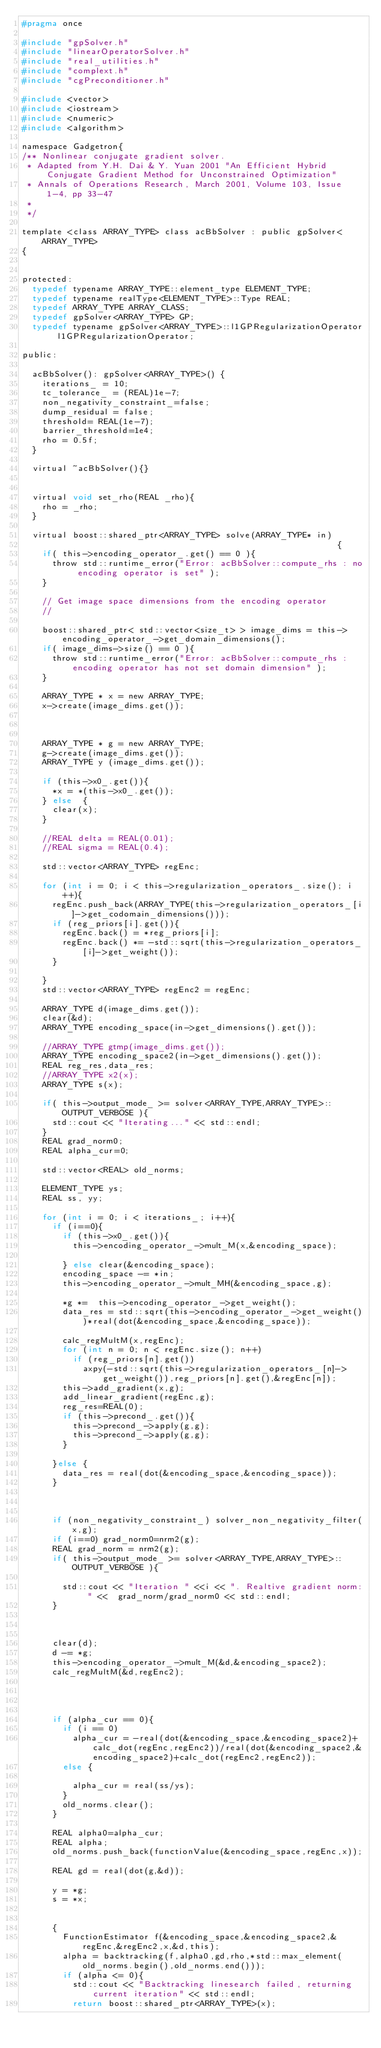Convert code to text. <code><loc_0><loc_0><loc_500><loc_500><_C_>#pragma once

#include "gpSolver.h"
#include "linearOperatorSolver.h"
#include "real_utilities.h"
#include "complext.h"
#include "cgPreconditioner.h"

#include <vector>
#include <iostream>
#include <numeric>
#include <algorithm>

namespace Gadgetron{
/** Nonlinear conjugate gradient solver.
 * Adapted from Y.H. Dai & Y. Yuan 2001 "An Efficient Hybrid Conjugate Gradient Method for Unconstrained Optimization"
 * Annals of Operations Research, March 2001, Volume 103, Issue 1-4, pp 33-47
 *
 */

template <class ARRAY_TYPE> class acBbSolver : public gpSolver<ARRAY_TYPE>
{


protected:
	typedef typename ARRAY_TYPE::element_type ELEMENT_TYPE;
	typedef typename realType<ELEMENT_TYPE>::Type REAL;
	typedef ARRAY_TYPE ARRAY_CLASS;
	typedef gpSolver<ARRAY_TYPE> GP;
	typedef typename gpSolver<ARRAY_TYPE>::l1GPRegularizationOperator l1GPRegularizationOperator;

public:

	acBbSolver(): gpSolver<ARRAY_TYPE>() {
		iterations_ = 10;
		tc_tolerance_ = (REAL)1e-7;
		non_negativity_constraint_=false;
		dump_residual = false;
		threshold= REAL(1e-7);
		barrier_threshold=1e4;
		rho = 0.5f;
	}

	virtual ~acBbSolver(){}


	virtual void set_rho(REAL _rho){
		rho = _rho;
	}

	virtual boost::shared_ptr<ARRAY_TYPE> solve(ARRAY_TYPE* in)
																															{
		if( this->encoding_operator_.get() == 0 ){
			throw std::runtime_error("Error: acBbSolver::compute_rhs : no encoding operator is set" );
		}

		// Get image space dimensions from the encoding operator
		//

		boost::shared_ptr< std::vector<size_t> > image_dims = this->encoding_operator_->get_domain_dimensions();
		if( image_dims->size() == 0 ){
			throw std::runtime_error("Error: acBbSolver::compute_rhs : encoding operator has not set domain dimension" );
		}

		ARRAY_TYPE * x = new ARRAY_TYPE;
		x->create(image_dims.get());



		ARRAY_TYPE * g = new ARRAY_TYPE;
		g->create(image_dims.get());
		ARRAY_TYPE y (image_dims.get());

		if (this->x0_.get()){
			*x = *(this->x0_.get());
		} else  {
			clear(x);
		}

		//REAL delta = REAL(0.01);
		//REAL sigma = REAL(0.4);

		std::vector<ARRAY_TYPE> regEnc;

		for (int i = 0; i < this->regularization_operators_.size(); i++){
			regEnc.push_back(ARRAY_TYPE(this->regularization_operators_[i]->get_codomain_dimensions()));
			if (reg_priors[i].get()){
				regEnc.back() = *reg_priors[i];
				regEnc.back() *= -std::sqrt(this->regularization_operators_[i]->get_weight());
			}

		}
		std::vector<ARRAY_TYPE> regEnc2 = regEnc;

		ARRAY_TYPE d(image_dims.get());
		clear(&d);
		ARRAY_TYPE encoding_space(in->get_dimensions().get());

		//ARRAY_TYPE gtmp(image_dims.get());
		ARRAY_TYPE encoding_space2(in->get_dimensions().get());
		REAL reg_res,data_res;
		//ARRAY_TYPE x2(x);
		ARRAY_TYPE s(x);

		if( this->output_mode_ >= solver<ARRAY_TYPE,ARRAY_TYPE>::OUTPUT_VERBOSE ){
			std::cout << "Iterating..." << std::endl;
		}
		REAL grad_norm0;
		REAL alpha_cur=0;

		std::vector<REAL> old_norms;

		ELEMENT_TYPE ys;
		REAL ss, yy;

		for (int i = 0; i < iterations_; i++){
			if (i==0){
				if (this->x0_.get()){
					this->encoding_operator_->mult_M(x,&encoding_space);

				} else clear(&encoding_space);
				encoding_space -= *in;
				this->encoding_operator_->mult_MH(&encoding_space,g);

				*g *=  this->encoding_operator_->get_weight();
				data_res = std::sqrt(this->encoding_operator_->get_weight())*real(dot(&encoding_space,&encoding_space));

				calc_regMultM(x,regEnc);
				for (int n = 0; n < regEnc.size(); n++)
					if (reg_priors[n].get())
						axpy(-std::sqrt(this->regularization_operators_[n]->get_weight()),reg_priors[n].get(),&regEnc[n]);
				this->add_gradient(x,g);
				add_linear_gradient(regEnc,g);
				reg_res=REAL(0);
				if (this->precond_.get()){
					this->precond_->apply(g,g);
					this->precond_->apply(g,g);
				}

			}else {
				data_res = real(dot(&encoding_space,&encoding_space));
			}



			if (non_negativity_constraint_) solver_non_negativity_filter(x,g);
			if (i==0) grad_norm0=nrm2(g);
			REAL grad_norm = nrm2(g);
			if( this->output_mode_ >= solver<ARRAY_TYPE,ARRAY_TYPE>::OUTPUT_VERBOSE ){

				std::cout << "Iteration " <<i << ". Realtive gradient norm: " <<  grad_norm/grad_norm0 << std::endl;
			}



			clear(d);
			d -= *g;
			this->encoding_operator_->mult_M(&d,&encoding_space2);
			calc_regMultM(&d,regEnc2);




			if (alpha_cur == 0){
				if (i == 0)
					alpha_cur = -real(dot(&encoding_space,&encoding_space2)+calc_dot(regEnc,regEnc2))/real(dot(&encoding_space2,&encoding_space2)+calc_dot(regEnc2,regEnc2));
				else {

					alpha_cur = real(ss/ys);
				}
				old_norms.clear();
			}

			REAL alpha0=alpha_cur;
			REAL alpha;
			old_norms.push_back(functionValue(&encoding_space,regEnc,x));

			REAL gd = real(dot(g,&d));

			y = *g;
			s = *x;


			{
				FunctionEstimator f(&encoding_space,&encoding_space2,&regEnc,&regEnc2,x,&d,this);
				alpha = backtracking(f,alpha0,gd,rho,*std::max_element(old_norms.begin(),old_norms.end()));
				if (alpha <= 0){
					std::cout << "Backtracking linesearch failed, returning current iteration" << std::endl;
					return boost::shared_ptr<ARRAY_TYPE>(x);</code> 